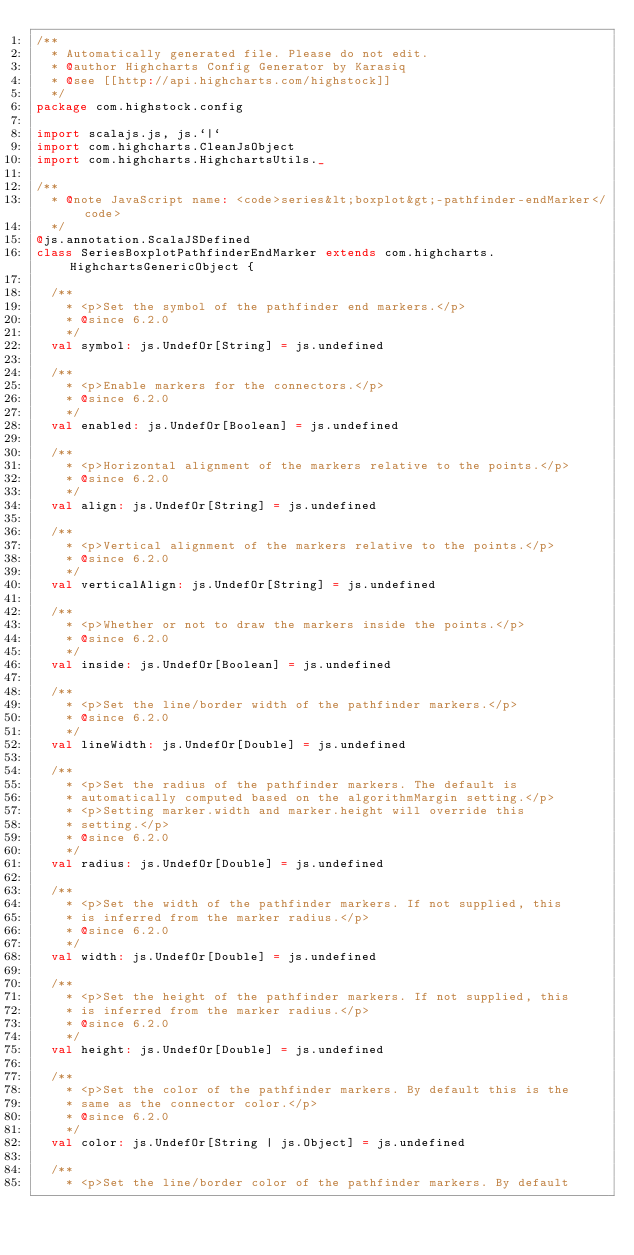<code> <loc_0><loc_0><loc_500><loc_500><_Scala_>/**
  * Automatically generated file. Please do not edit.
  * @author Highcharts Config Generator by Karasiq
  * @see [[http://api.highcharts.com/highstock]]
  */
package com.highstock.config

import scalajs.js, js.`|`
import com.highcharts.CleanJsObject
import com.highcharts.HighchartsUtils._

/**
  * @note JavaScript name: <code>series&lt;boxplot&gt;-pathfinder-endMarker</code>
  */
@js.annotation.ScalaJSDefined
class SeriesBoxplotPathfinderEndMarker extends com.highcharts.HighchartsGenericObject {

  /**
    * <p>Set the symbol of the pathfinder end markers.</p>
    * @since 6.2.0
    */
  val symbol: js.UndefOr[String] = js.undefined

  /**
    * <p>Enable markers for the connectors.</p>
    * @since 6.2.0
    */
  val enabled: js.UndefOr[Boolean] = js.undefined

  /**
    * <p>Horizontal alignment of the markers relative to the points.</p>
    * @since 6.2.0
    */
  val align: js.UndefOr[String] = js.undefined

  /**
    * <p>Vertical alignment of the markers relative to the points.</p>
    * @since 6.2.0
    */
  val verticalAlign: js.UndefOr[String] = js.undefined

  /**
    * <p>Whether or not to draw the markers inside the points.</p>
    * @since 6.2.0
    */
  val inside: js.UndefOr[Boolean] = js.undefined

  /**
    * <p>Set the line/border width of the pathfinder markers.</p>
    * @since 6.2.0
    */
  val lineWidth: js.UndefOr[Double] = js.undefined

  /**
    * <p>Set the radius of the pathfinder markers. The default is
    * automatically computed based on the algorithmMargin setting.</p>
    * <p>Setting marker.width and marker.height will override this
    * setting.</p>
    * @since 6.2.0
    */
  val radius: js.UndefOr[Double] = js.undefined

  /**
    * <p>Set the width of the pathfinder markers. If not supplied, this
    * is inferred from the marker radius.</p>
    * @since 6.2.0
    */
  val width: js.UndefOr[Double] = js.undefined

  /**
    * <p>Set the height of the pathfinder markers. If not supplied, this
    * is inferred from the marker radius.</p>
    * @since 6.2.0
    */
  val height: js.UndefOr[Double] = js.undefined

  /**
    * <p>Set the color of the pathfinder markers. By default this is the
    * same as the connector color.</p>
    * @since 6.2.0
    */
  val color: js.UndefOr[String | js.Object] = js.undefined

  /**
    * <p>Set the line/border color of the pathfinder markers. By default</code> 